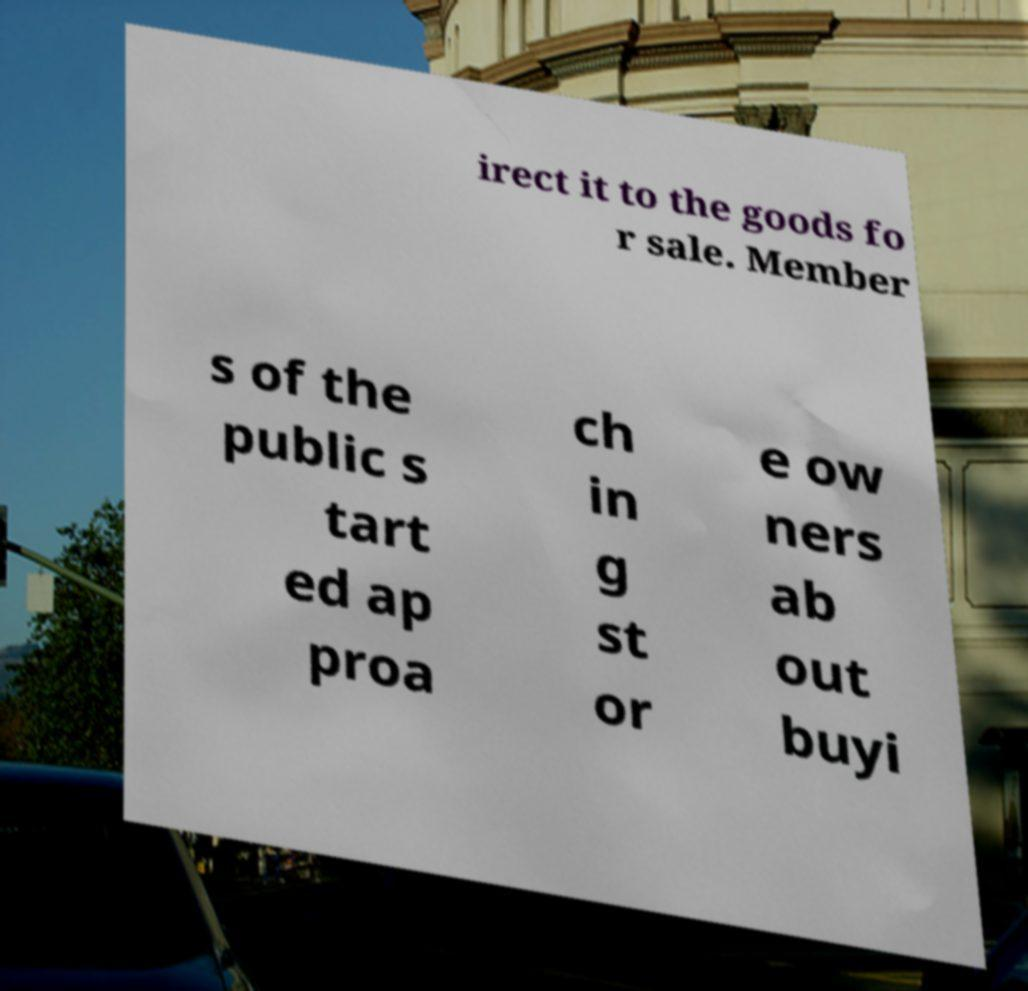Can you accurately transcribe the text from the provided image for me? irect it to the goods fo r sale. Member s of the public s tart ed ap proa ch in g st or e ow ners ab out buyi 